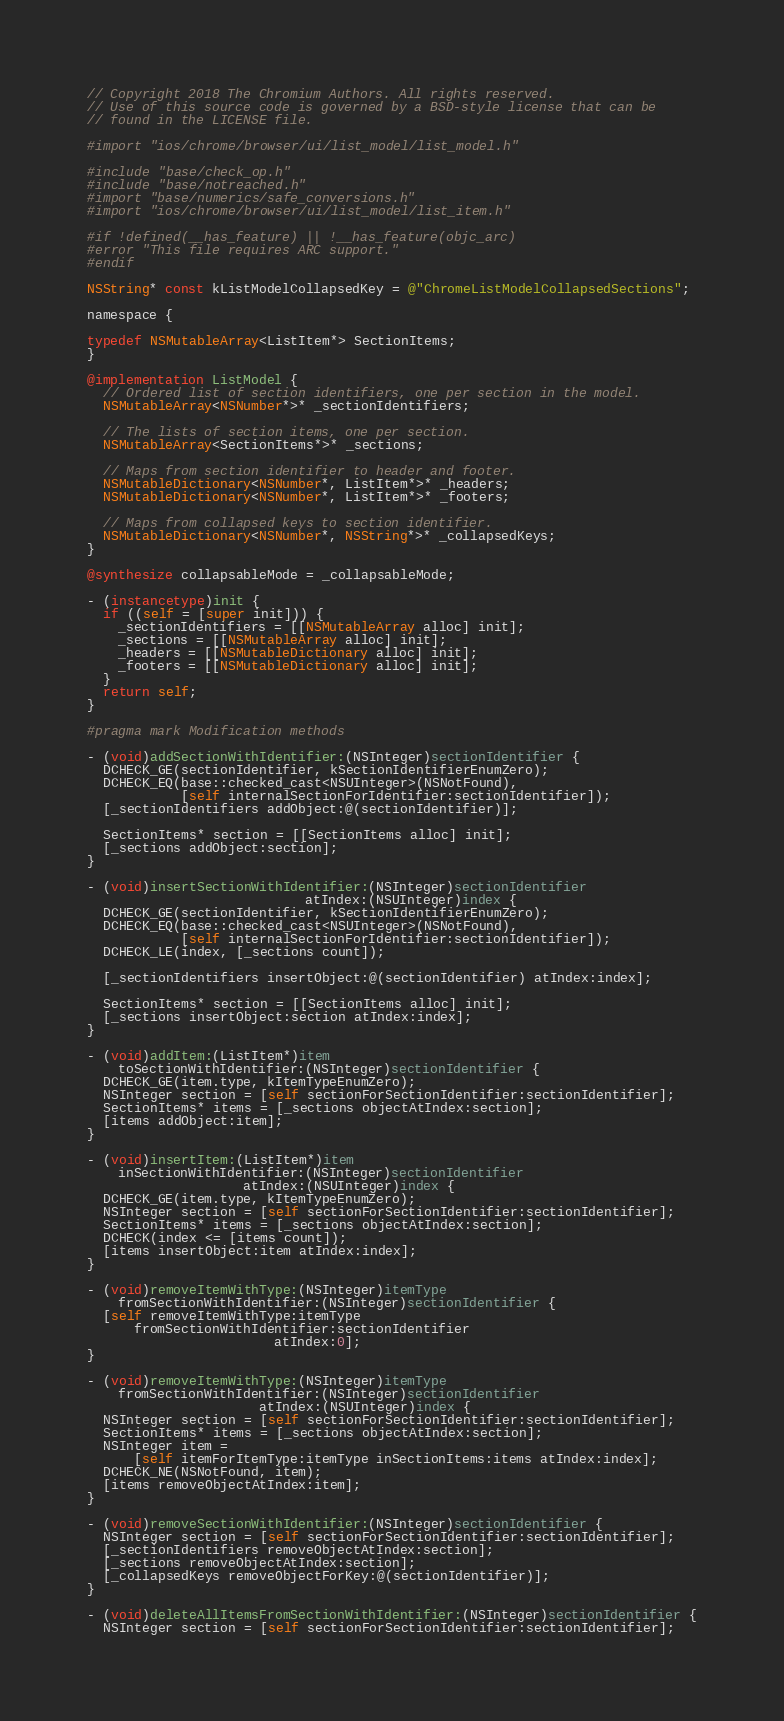Convert code to text. <code><loc_0><loc_0><loc_500><loc_500><_ObjectiveC_>// Copyright 2018 The Chromium Authors. All rights reserved.
// Use of this source code is governed by a BSD-style license that can be
// found in the LICENSE file.

#import "ios/chrome/browser/ui/list_model/list_model.h"

#include "base/check_op.h"
#include "base/notreached.h"
#import "base/numerics/safe_conversions.h"
#import "ios/chrome/browser/ui/list_model/list_item.h"

#if !defined(__has_feature) || !__has_feature(objc_arc)
#error "This file requires ARC support."
#endif

NSString* const kListModelCollapsedKey = @"ChromeListModelCollapsedSections";

namespace {

typedef NSMutableArray<ListItem*> SectionItems;
}

@implementation ListModel {
  // Ordered list of section identifiers, one per section in the model.
  NSMutableArray<NSNumber*>* _sectionIdentifiers;

  // The lists of section items, one per section.
  NSMutableArray<SectionItems*>* _sections;

  // Maps from section identifier to header and footer.
  NSMutableDictionary<NSNumber*, ListItem*>* _headers;
  NSMutableDictionary<NSNumber*, ListItem*>* _footers;

  // Maps from collapsed keys to section identifier.
  NSMutableDictionary<NSNumber*, NSString*>* _collapsedKeys;
}

@synthesize collapsableMode = _collapsableMode;

- (instancetype)init {
  if ((self = [super init])) {
    _sectionIdentifiers = [[NSMutableArray alloc] init];
    _sections = [[NSMutableArray alloc] init];
    _headers = [[NSMutableDictionary alloc] init];
    _footers = [[NSMutableDictionary alloc] init];
  }
  return self;
}

#pragma mark Modification methods

- (void)addSectionWithIdentifier:(NSInteger)sectionIdentifier {
  DCHECK_GE(sectionIdentifier, kSectionIdentifierEnumZero);
  DCHECK_EQ(base::checked_cast<NSUInteger>(NSNotFound),
            [self internalSectionForIdentifier:sectionIdentifier]);
  [_sectionIdentifiers addObject:@(sectionIdentifier)];

  SectionItems* section = [[SectionItems alloc] init];
  [_sections addObject:section];
}

- (void)insertSectionWithIdentifier:(NSInteger)sectionIdentifier
                            atIndex:(NSUInteger)index {
  DCHECK_GE(sectionIdentifier, kSectionIdentifierEnumZero);
  DCHECK_EQ(base::checked_cast<NSUInteger>(NSNotFound),
            [self internalSectionForIdentifier:sectionIdentifier]);
  DCHECK_LE(index, [_sections count]);

  [_sectionIdentifiers insertObject:@(sectionIdentifier) atIndex:index];

  SectionItems* section = [[SectionItems alloc] init];
  [_sections insertObject:section atIndex:index];
}

- (void)addItem:(ListItem*)item
    toSectionWithIdentifier:(NSInteger)sectionIdentifier {
  DCHECK_GE(item.type, kItemTypeEnumZero);
  NSInteger section = [self sectionForSectionIdentifier:sectionIdentifier];
  SectionItems* items = [_sections objectAtIndex:section];
  [items addObject:item];
}

- (void)insertItem:(ListItem*)item
    inSectionWithIdentifier:(NSInteger)sectionIdentifier
                    atIndex:(NSUInteger)index {
  DCHECK_GE(item.type, kItemTypeEnumZero);
  NSInteger section = [self sectionForSectionIdentifier:sectionIdentifier];
  SectionItems* items = [_sections objectAtIndex:section];
  DCHECK(index <= [items count]);
  [items insertObject:item atIndex:index];
}

- (void)removeItemWithType:(NSInteger)itemType
    fromSectionWithIdentifier:(NSInteger)sectionIdentifier {
  [self removeItemWithType:itemType
      fromSectionWithIdentifier:sectionIdentifier
                        atIndex:0];
}

- (void)removeItemWithType:(NSInteger)itemType
    fromSectionWithIdentifier:(NSInteger)sectionIdentifier
                      atIndex:(NSUInteger)index {
  NSInteger section = [self sectionForSectionIdentifier:sectionIdentifier];
  SectionItems* items = [_sections objectAtIndex:section];
  NSInteger item =
      [self itemForItemType:itemType inSectionItems:items atIndex:index];
  DCHECK_NE(NSNotFound, item);
  [items removeObjectAtIndex:item];
}

- (void)removeSectionWithIdentifier:(NSInteger)sectionIdentifier {
  NSInteger section = [self sectionForSectionIdentifier:sectionIdentifier];
  [_sectionIdentifiers removeObjectAtIndex:section];
  [_sections removeObjectAtIndex:section];
  [_collapsedKeys removeObjectForKey:@(sectionIdentifier)];
}

- (void)deleteAllItemsFromSectionWithIdentifier:(NSInteger)sectionIdentifier {
  NSInteger section = [self sectionForSectionIdentifier:sectionIdentifier];</code> 